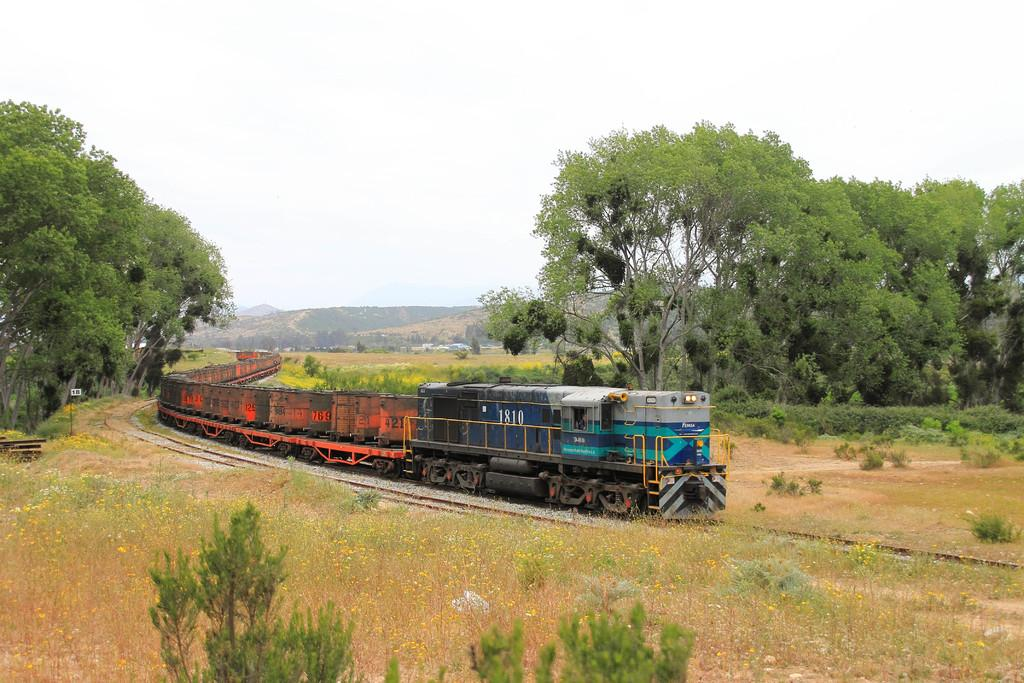What is the main subject of the image? The main subject of the image is a train on the track. What can be seen in the foreground of the image? There are plants and grass visible in the image. What is visible in the background of the image? There are trees and mountains in the background of the image. What is visible at the top of the image? The sky is visible at the top of the image. When was the image taken? The image was taken during the day. What type of vegetable is being harvested by the army in the image? There is no vegetable or army present in the image; it features a train on a track with plants, grass, trees, mountains, and the sky. 